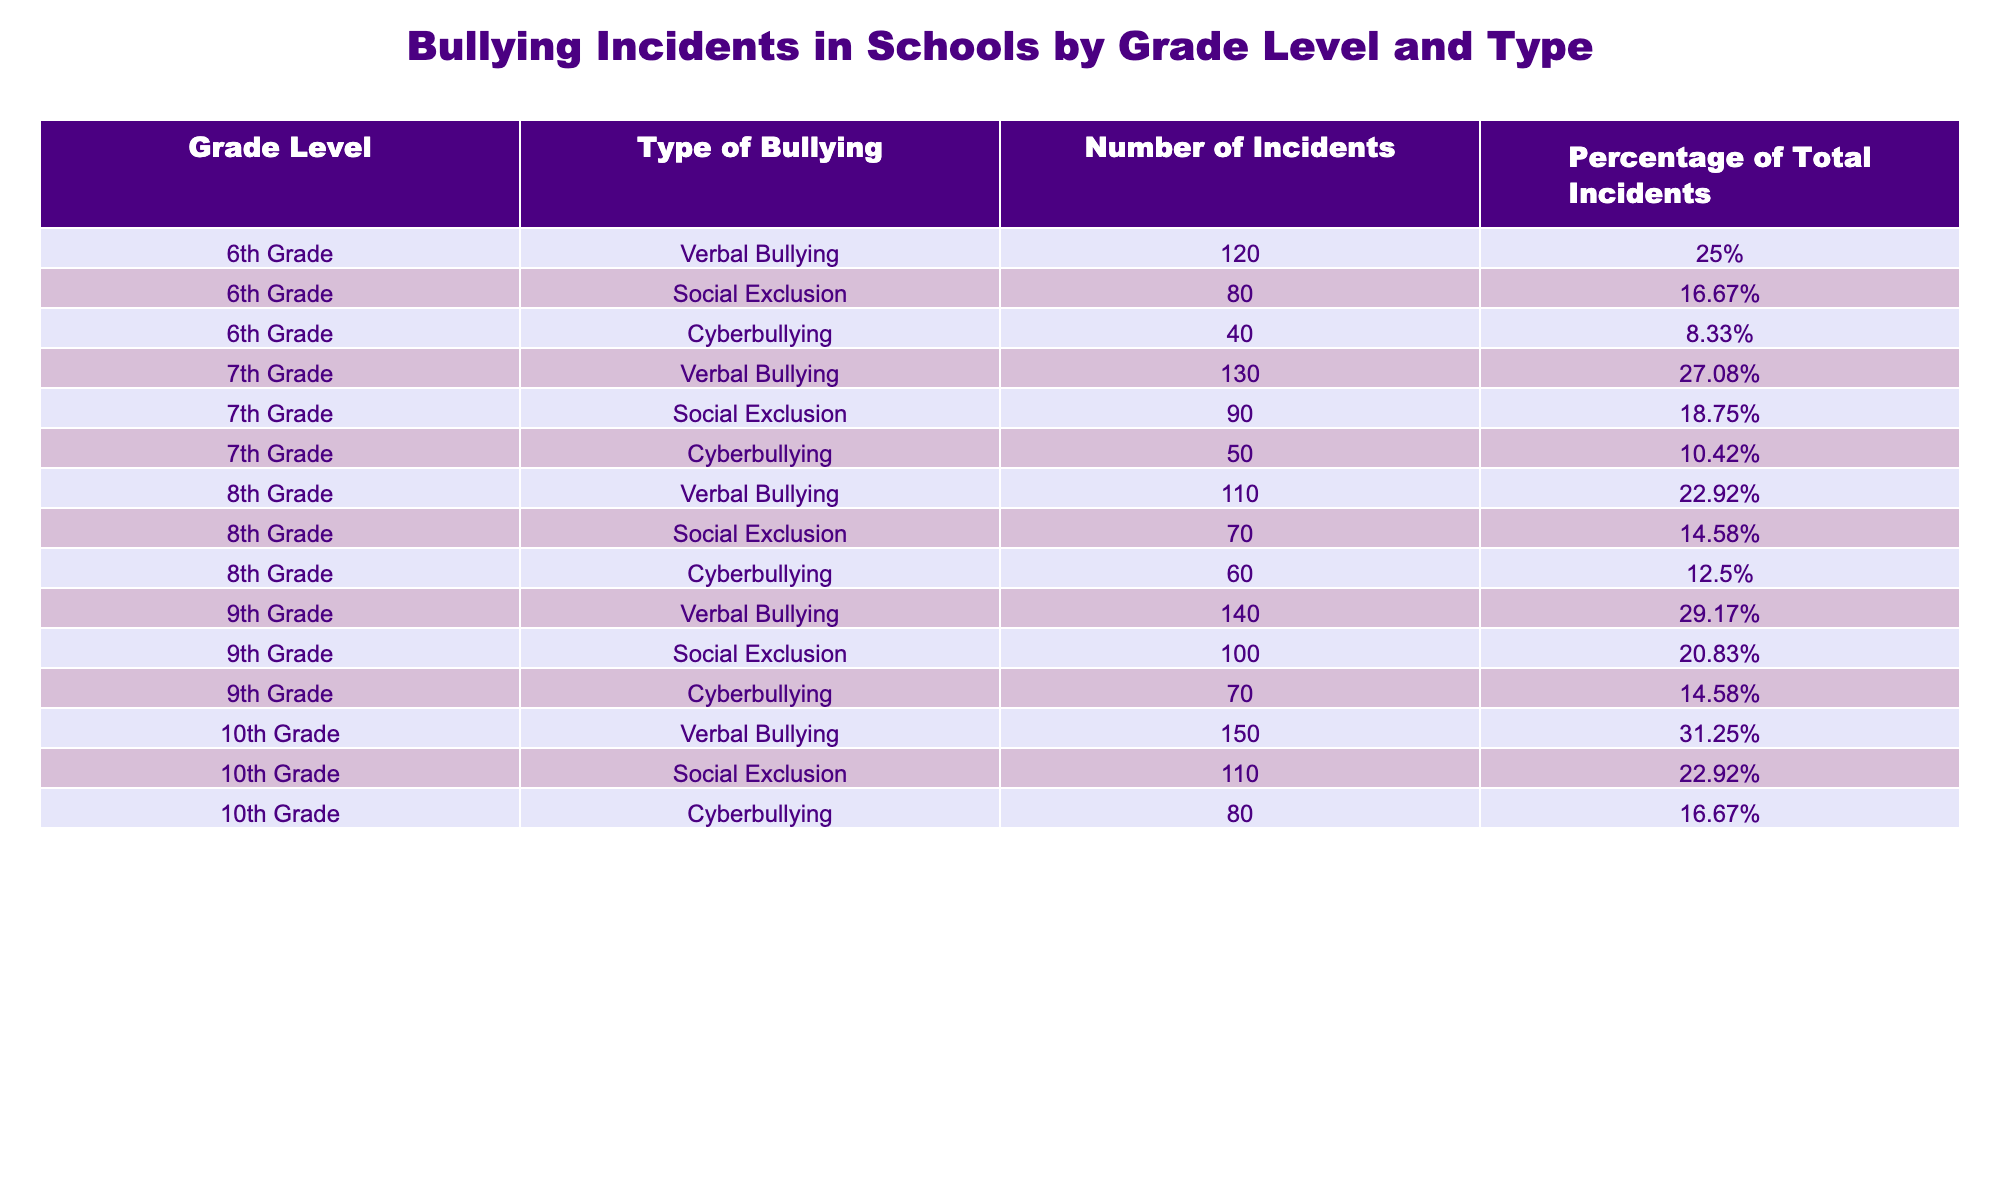What type of bullying had the highest number of incidents in 10th Grade? In the table, under 10th Grade, the types of bullying are listed with their respective number of incidents: Verbal Bullying (150), Social Exclusion (110), and Cyberbullying (80). The highest number is for Verbal Bullying.
Answer: Verbal Bullying How many more incidents of Social Exclusion were there in 9th Grade compared to 8th Grade? In 9th Grade, the number of Social Exclusion incidents is 100, and in 8th Grade, it is 70. Subtracting these values (100 - 70) gives us 30 more incidents in 9th Grade.
Answer: 30 Is the percentage of Cyberbullying incidents in 7th Grade higher than in 6th Grade? In 7th Grade, the percentage of Cyberbullying incidents is 10.42%, while in 6th Grade, it is 8.33%. Since 10.42% is greater than 8.33%, the statement is true.
Answer: Yes What is the total number of bullying incidents reported in 8th Grade? The incidents in 8th Grade are: Verbal Bullying (110), Social Exclusion (70), and Cyberbullying (60). Adding these together gives (110 + 70 + 60) = 240 incidents.
Answer: 240 Which grade level has the lowest number of incidents overall? I need to sum the number of incidents for each grade level: 6th Grade (120 + 80 + 40 = 240), 7th Grade (130 + 90 + 50 = 270), 8th Grade (110 + 70 + 60 = 240), 9th Grade (140 + 100 + 70 = 310), and 10th Grade (150 + 110 + 80 = 340). The lowest total is for 6th Grade and 8th Grade with 240 incidents each.
Answer: 6th Grade and 8th Grade What is the average number of incidents for Social Exclusion across all grade levels? The total incidents for Social Exclusion are: 80 (6th) + 90 (7th) + 70 (8th) + 100 (9th) + 110 (10th) = 450. There are 5 grade levels, so the average is 450 / 5 = 90.
Answer: 90 